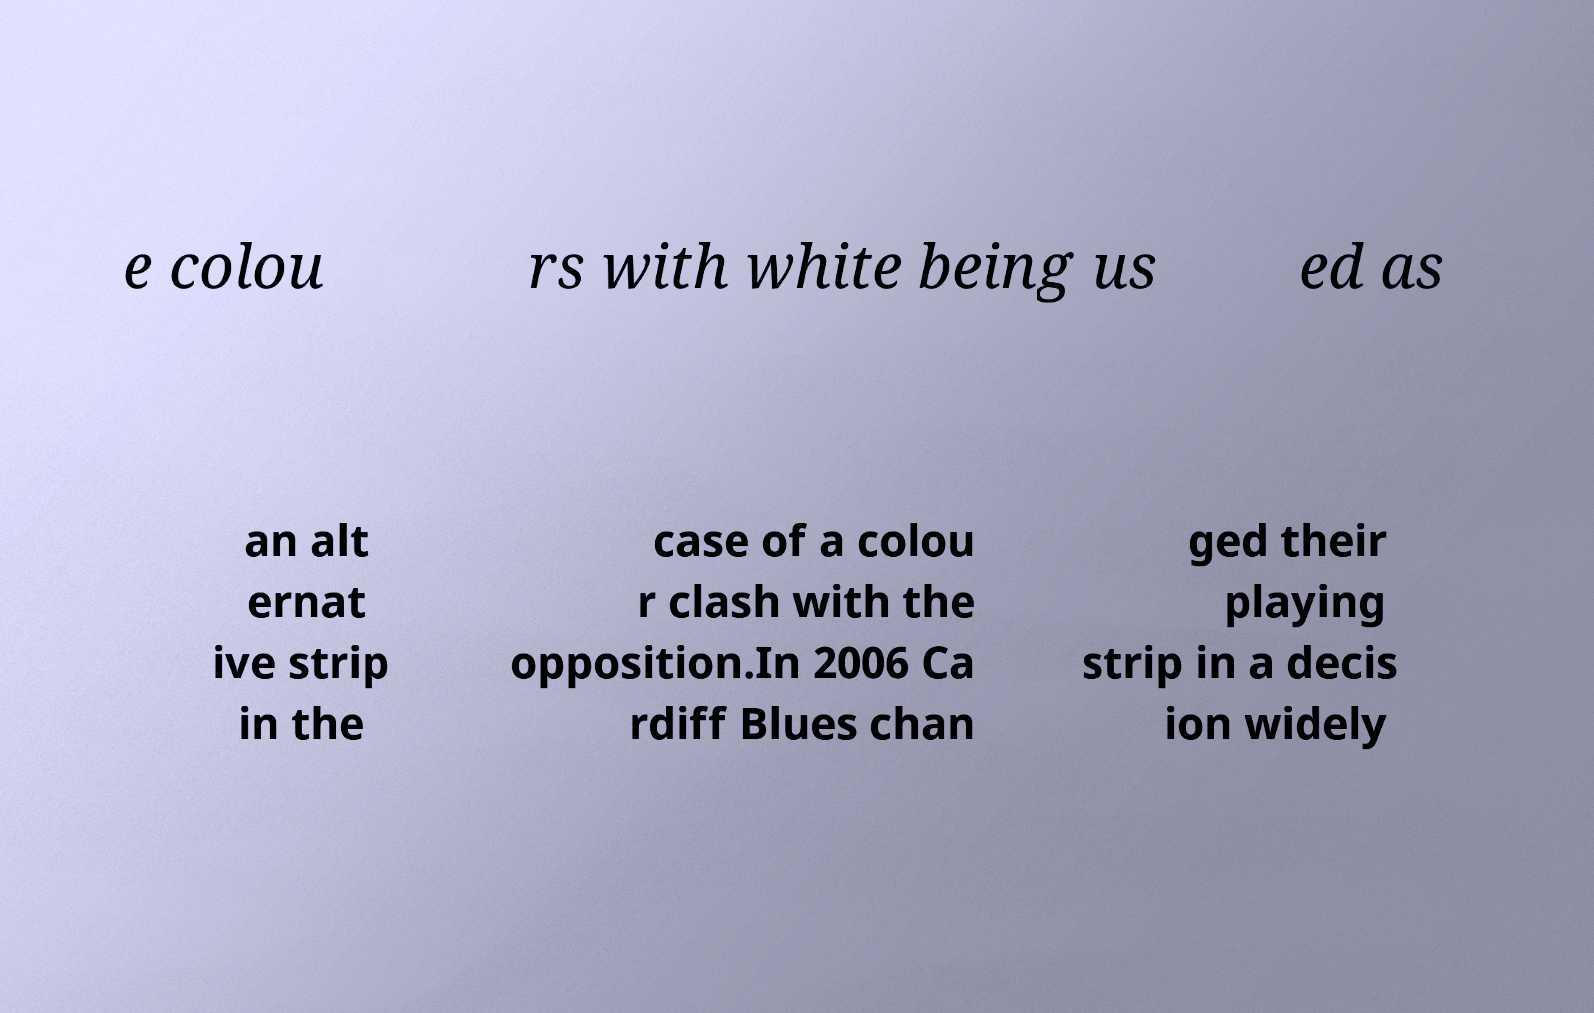What messages or text are displayed in this image? I need them in a readable, typed format. e colou rs with white being us ed as an alt ernat ive strip in the case of a colou r clash with the opposition.In 2006 Ca rdiff Blues chan ged their playing strip in a decis ion widely 